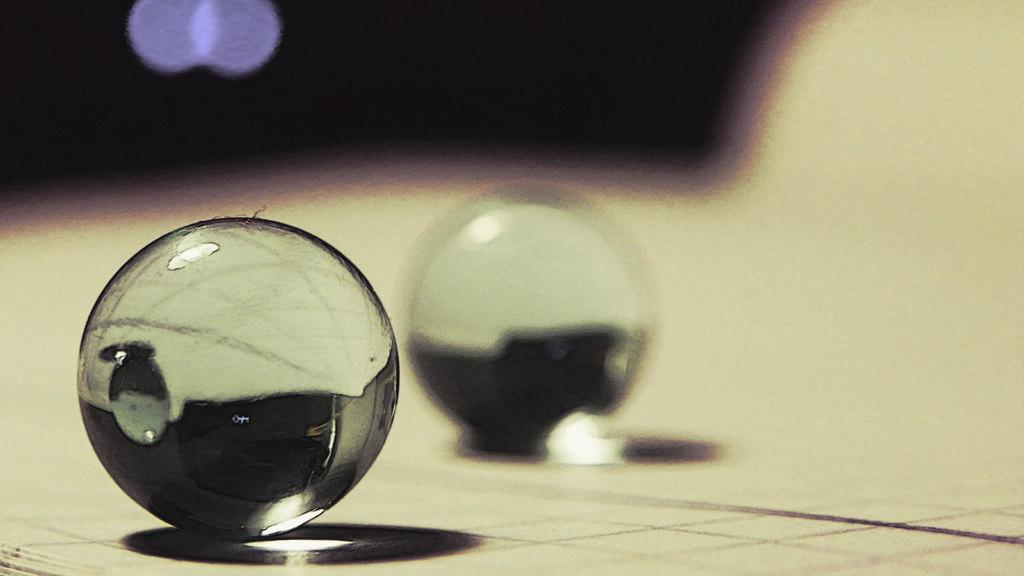What shape is the main object in the image? The main object in the image is a sphere. What is the color of the sphere? The sphere is transparent in color. Can you describe the background of the image? The background of the image is blurred. What type of machine can be seen in the background of the image? There is no machine present in the image; the background is blurred. Is there a fire visible in the image? There is no fire present in the image; it only features a transparent sphere. Can you spot an owl in the image? There is no owl present in the image; it only features a transparent sphere. 